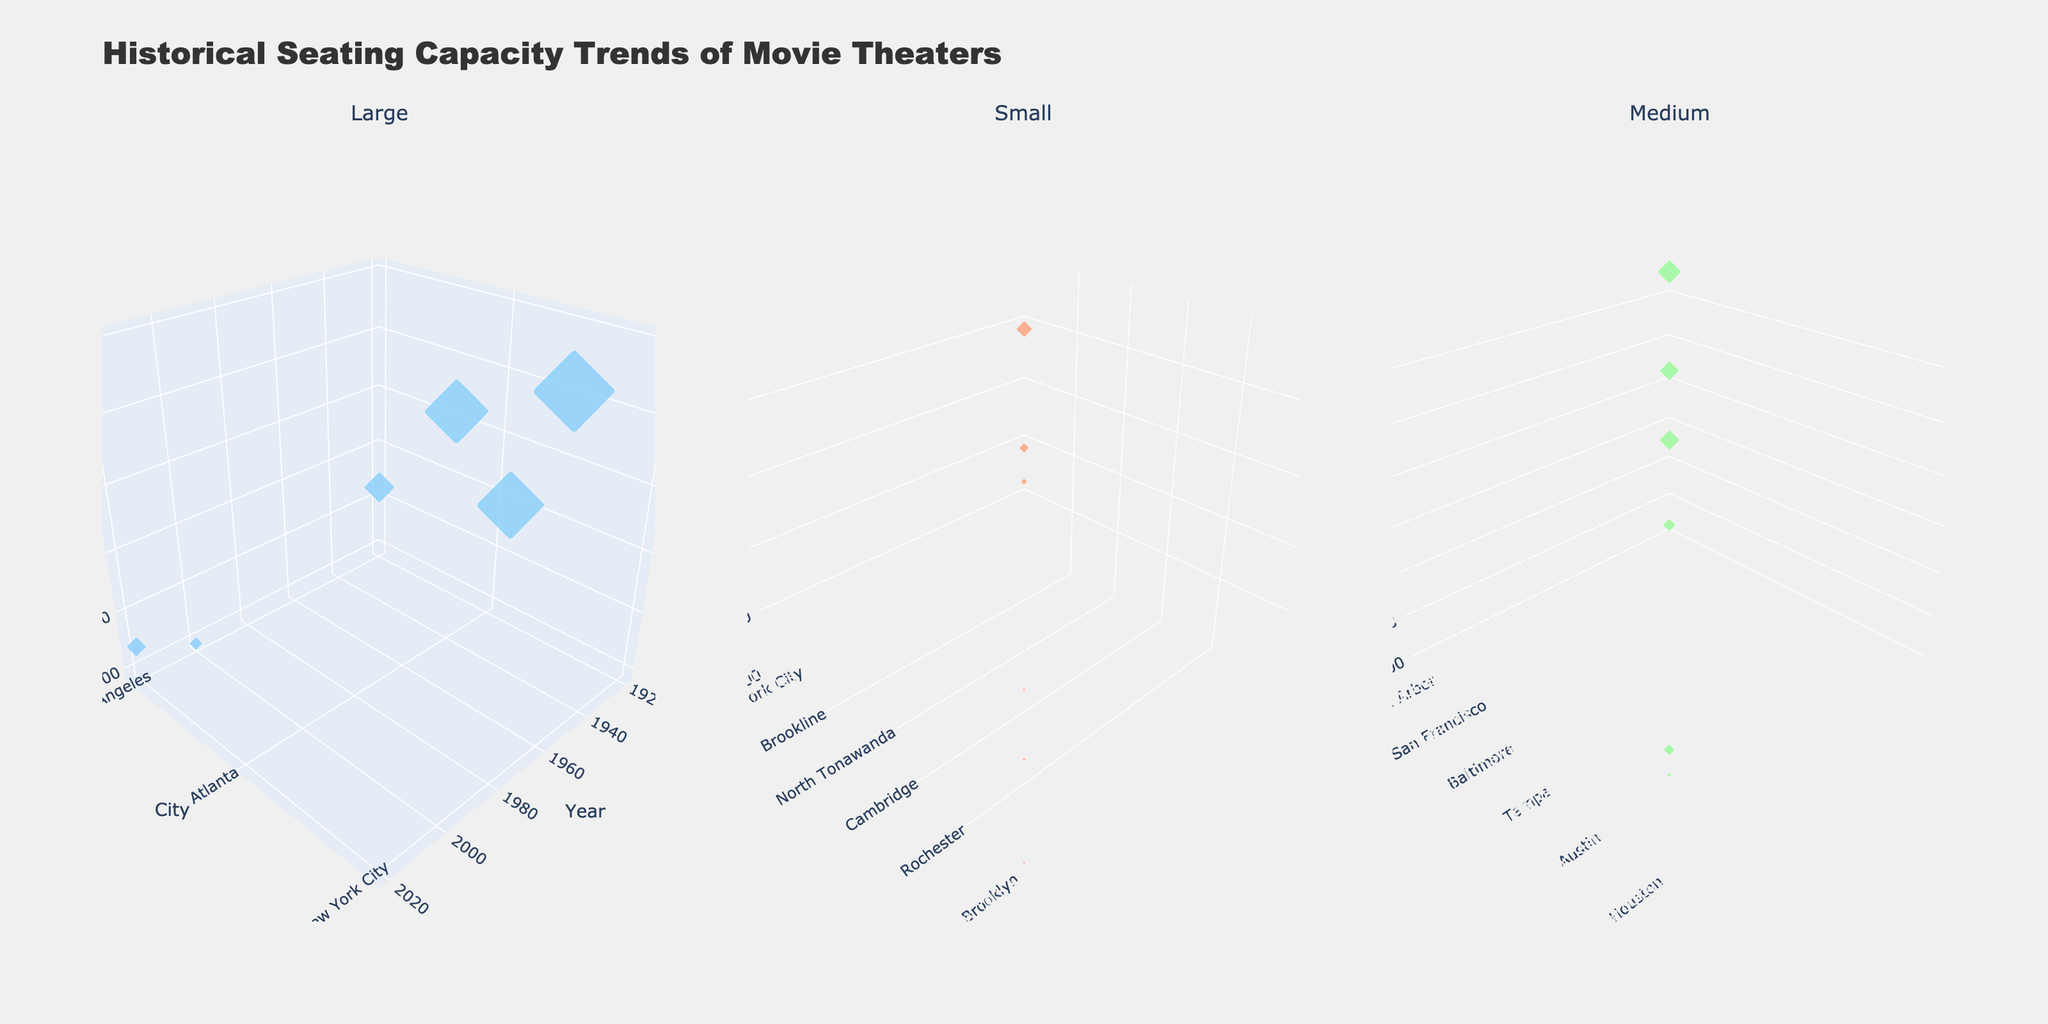What is the title of the figure? The title of the figure is displayed prominently at the top of the chart. It provides a description of what the figure represents.
Answer: "Historical Seating Capacity Trends of Movie Theaters" How is the seating capacity represented in the figure? The seating capacity is represented by the size of the markers in the plot. Larger markers indicate a higher seating capacity, and smaller markers indicate a lower seating capacity.
Answer: By the size of the markers Which city appears in all three subplot sections? New York City appears in all three subplots since it has small, medium, and large-sized theaters represented in the dataset.
Answer: New York City What is the seating capacity of the largest theater shown in the 1960 subplot? The largest theater in the 1960 subplot is Radio City Music Hall in New York City with a seating capacity of 5960.
Answer: 5960 How many unique theaters are represented in the 2000 subplot? We can count the individual theaters in the 2000 subplot. There are three theaters: Alamo Drafthouse Cinema, TCL Chinese Theatre, and The Little Theatre.
Answer: Three How does the seating capacity trend from 1920 to 2020 in Los Angeles for large theaters? In Los Angeles for large theaters, the seating capacity decreases over time from 2200 in 1920 (Orpheum Theater) to 932 in 2000 (TCL Chinese Theatre), and then slightly increases to 1400 in 2020 (ArcLight Hollywood).
Answer: Decreases then slightly increases Compare the seating capacities of large theaters in New York City between 1920 and 1960. Which year had the larger seating capacity? To compare, look at the seating capacities of theaters in New York City labeled as large for both years. In 1920, there is no large theater listed, but, in 1960, Radio City Music Hall has a seating capacity of 5960.
Answer: 1960 Which year showed the highest average seating capacity for medium-sized theaters? To find this, average the seating capacities of medium-sized theaters for each year and compare. In 1920, 1940, 1960, 1980, 2000, and 2020: (1700+1400+900+1446+320+800)/6 = 594. The highest average occurs in 1980 (1446).
Answer: 1980 Are there any cities that have theaters of all three sizes represented in the dataset? By examining all subplots for the occurrence of each theater size within the same city, we find that New York City has theaters of all three sizes.
Answer: Yes, New York City 